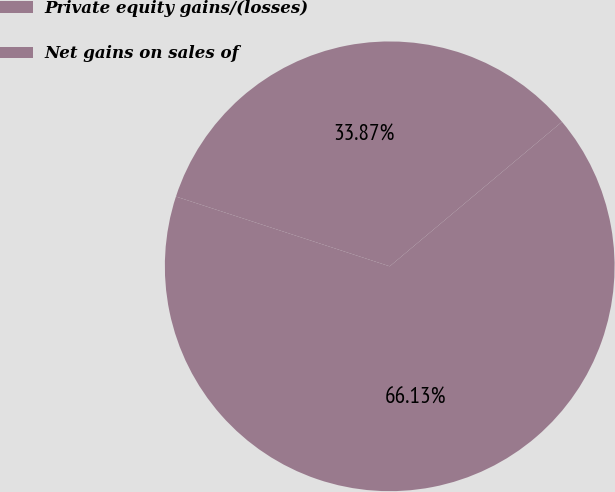<chart> <loc_0><loc_0><loc_500><loc_500><pie_chart><fcel>Private equity gains/(losses)<fcel>Net gains on sales of<nl><fcel>33.87%<fcel>66.13%<nl></chart> 